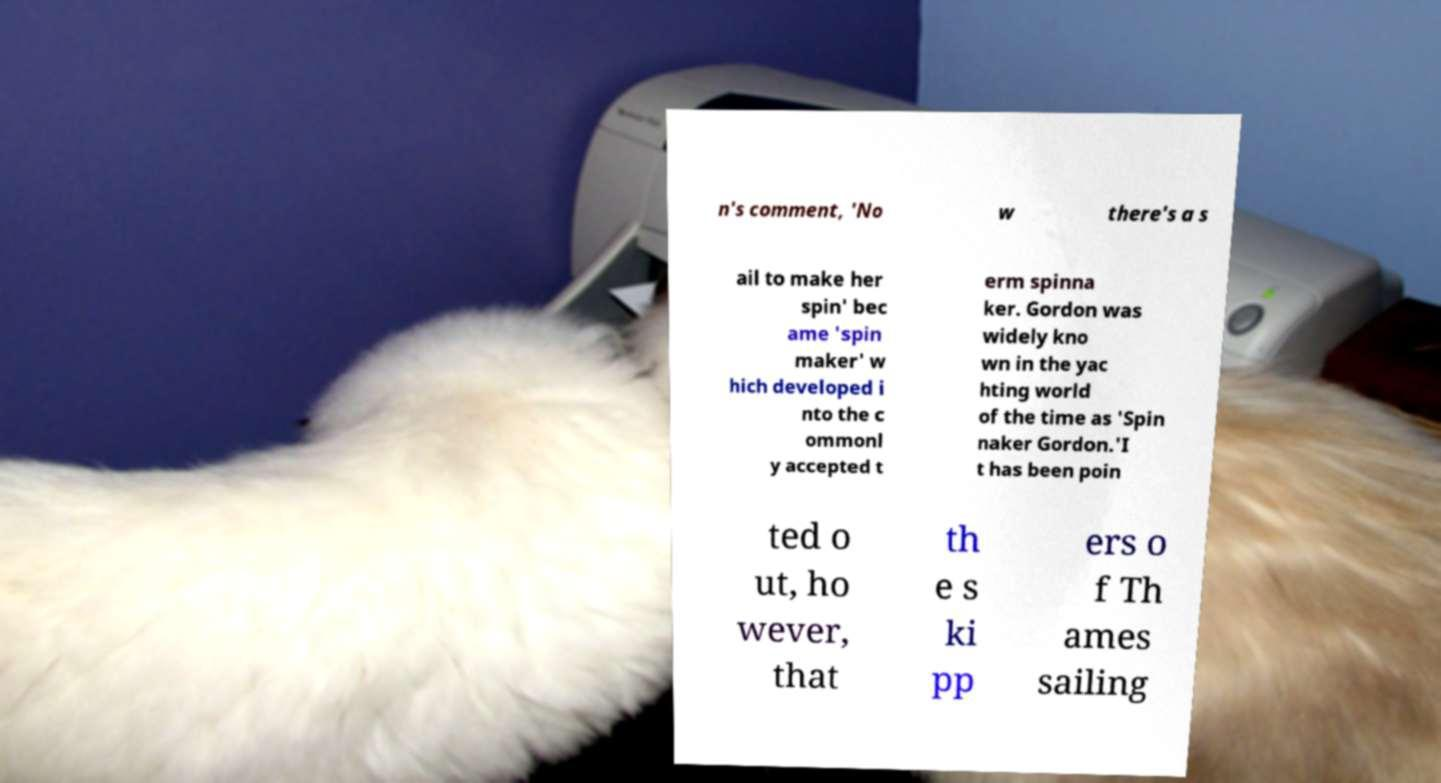What messages or text are displayed in this image? I need them in a readable, typed format. n's comment, 'No w there's a s ail to make her spin' bec ame 'spin maker' w hich developed i nto the c ommonl y accepted t erm spinna ker. Gordon was widely kno wn in the yac hting world of the time as 'Spin naker Gordon.'I t has been poin ted o ut, ho wever, that th e s ki pp ers o f Th ames sailing 